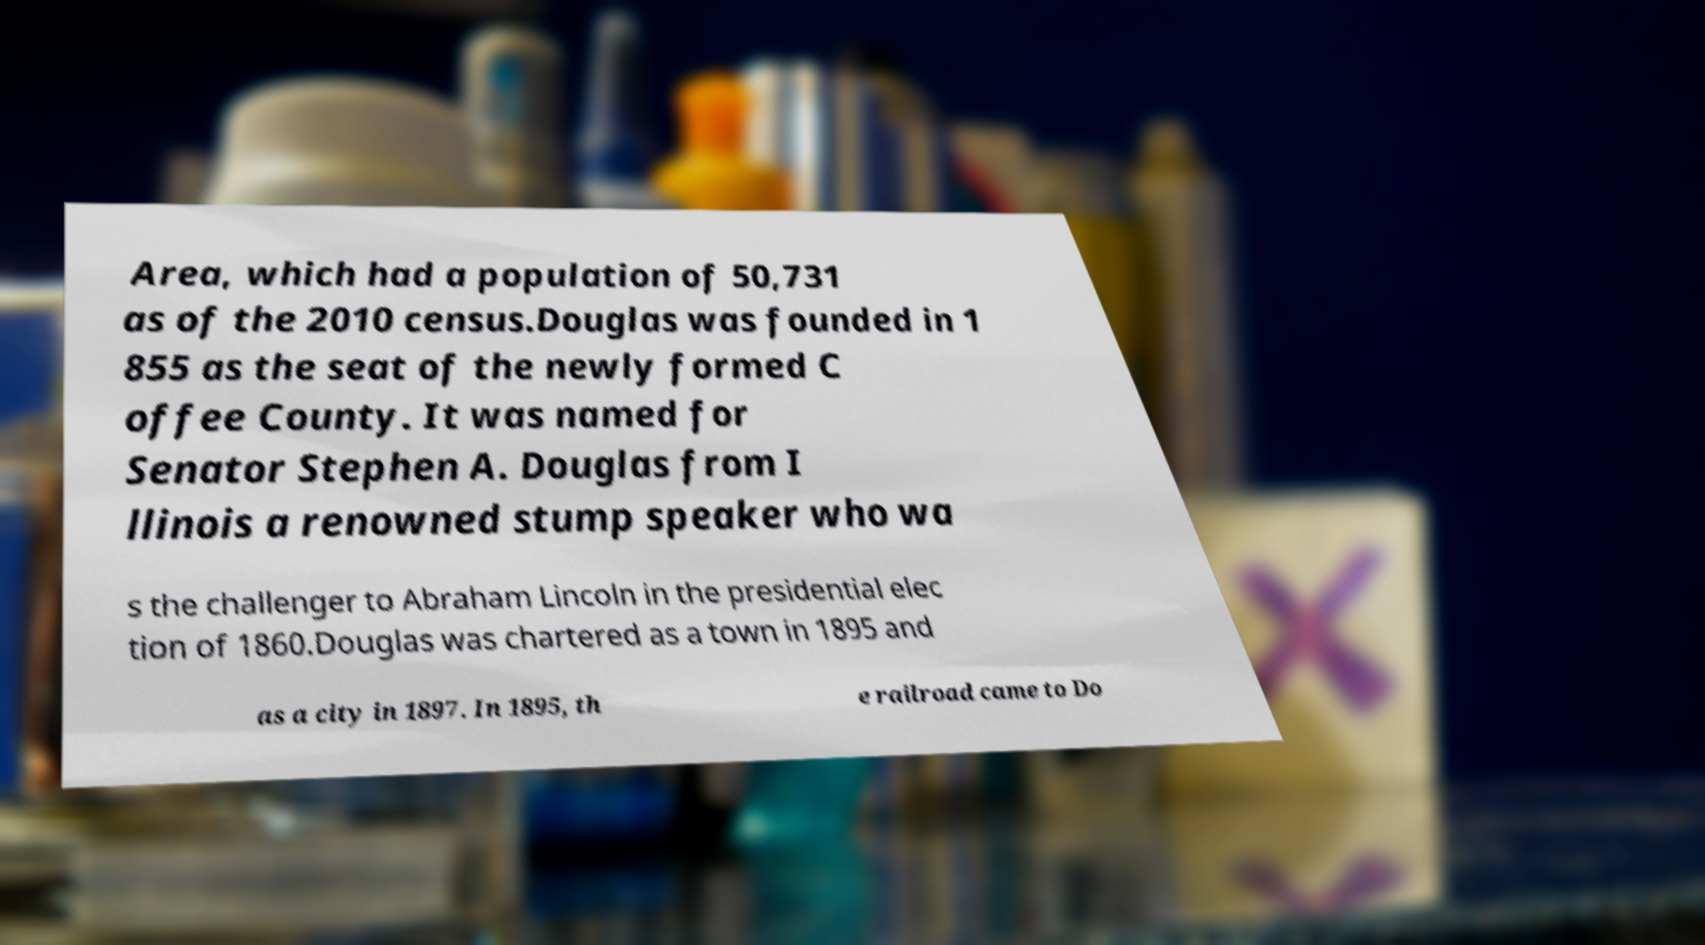What messages or text are displayed in this image? I need them in a readable, typed format. Area, which had a population of 50,731 as of the 2010 census.Douglas was founded in 1 855 as the seat of the newly formed C offee County. It was named for Senator Stephen A. Douglas from I llinois a renowned stump speaker who wa s the challenger to Abraham Lincoln in the presidential elec tion of 1860.Douglas was chartered as a town in 1895 and as a city in 1897. In 1895, th e railroad came to Do 